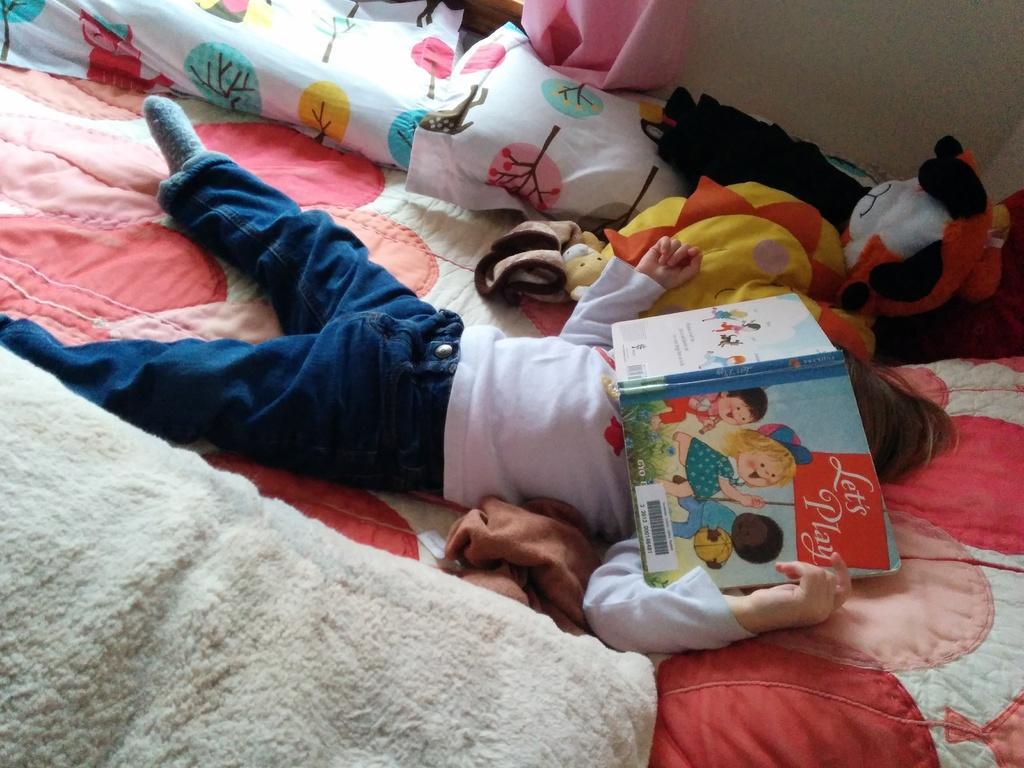Describe this image in one or two sentences. This picture is taken inside the room. In this image, in the middle, we can see a kid lying on the bed and keeping book on her face. On the left corner, we can see a blanket. In the background, we can see some pillows, toys and a wall. 